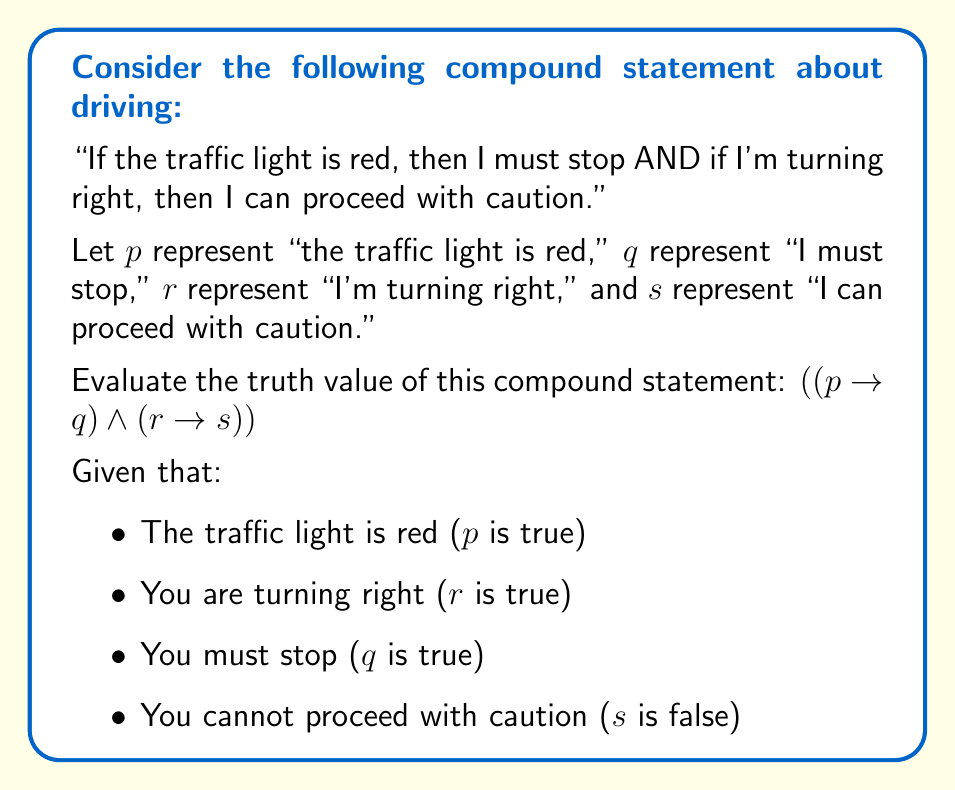Solve this math problem. Let's break this down step by step:

1) We have a compound statement consisting of two implications connected by a conjunction (AND):
   $((p \rightarrow q) \wedge (r \rightarrow s))$

2) Let's evaluate each implication separately:

   a) $(p \rightarrow q)$:
      - $p$ is true (the traffic light is red)
      - $q$ is true (you must stop)
      - In an implication, if both the antecedent and consequent are true, the implication is true.
      Therefore, $(p \rightarrow q)$ is true.

   b) $(r \rightarrow s)$:
      - $r$ is true (you are turning right)
      - $s$ is false (you cannot proceed with caution)
      - In an implication, if the antecedent is true and the consequent is false, the implication is false.
      Therefore, $(r \rightarrow s)$ is false.

3) Now we have:
   $(true \wedge false)$

4) The truth table for conjunction (AND) states that:
   $true \wedge false = false$

Therefore, the entire compound statement $((p \rightarrow q) \wedge (r \rightarrow s))$ evaluates to false.
Answer: False 